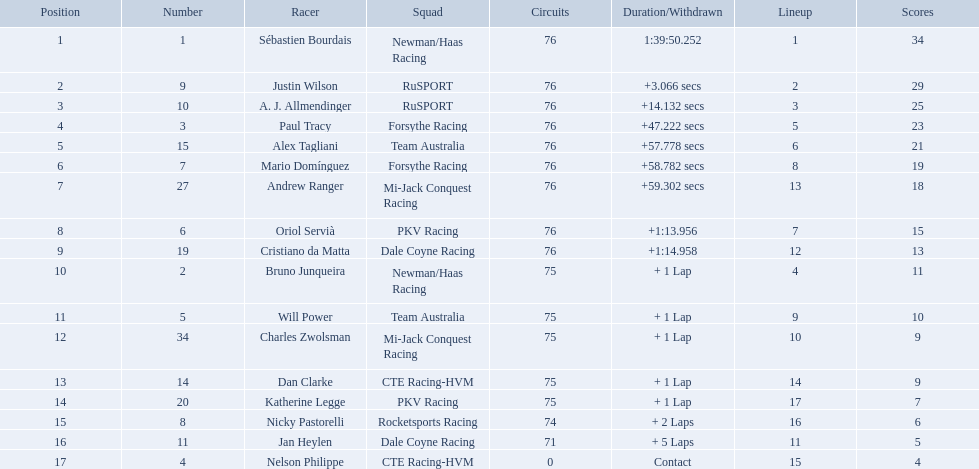What drivers took part in the 2006 tecate grand prix of monterrey? Sébastien Bourdais, Justin Wilson, A. J. Allmendinger, Paul Tracy, Alex Tagliani, Mario Domínguez, Andrew Ranger, Oriol Servià, Cristiano da Matta, Bruno Junqueira, Will Power, Charles Zwolsman, Dan Clarke, Katherine Legge, Nicky Pastorelli, Jan Heylen, Nelson Philippe. Which of those drivers scored the same amount of points as another driver? Charles Zwolsman, Dan Clarke. Who had the same amount of points as charles zwolsman? Dan Clarke. 